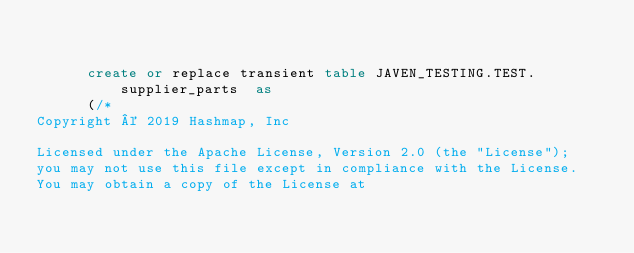Convert code to text. <code><loc_0><loc_0><loc_500><loc_500><_SQL_>

      create or replace transient table JAVEN_TESTING.TEST.supplier_parts  as
      (/*
Copyright © 2019 Hashmap, Inc

Licensed under the Apache License, Version 2.0 (the "License");
you may not use this file except in compliance with the License.
You may obtain a copy of the License at
</code> 